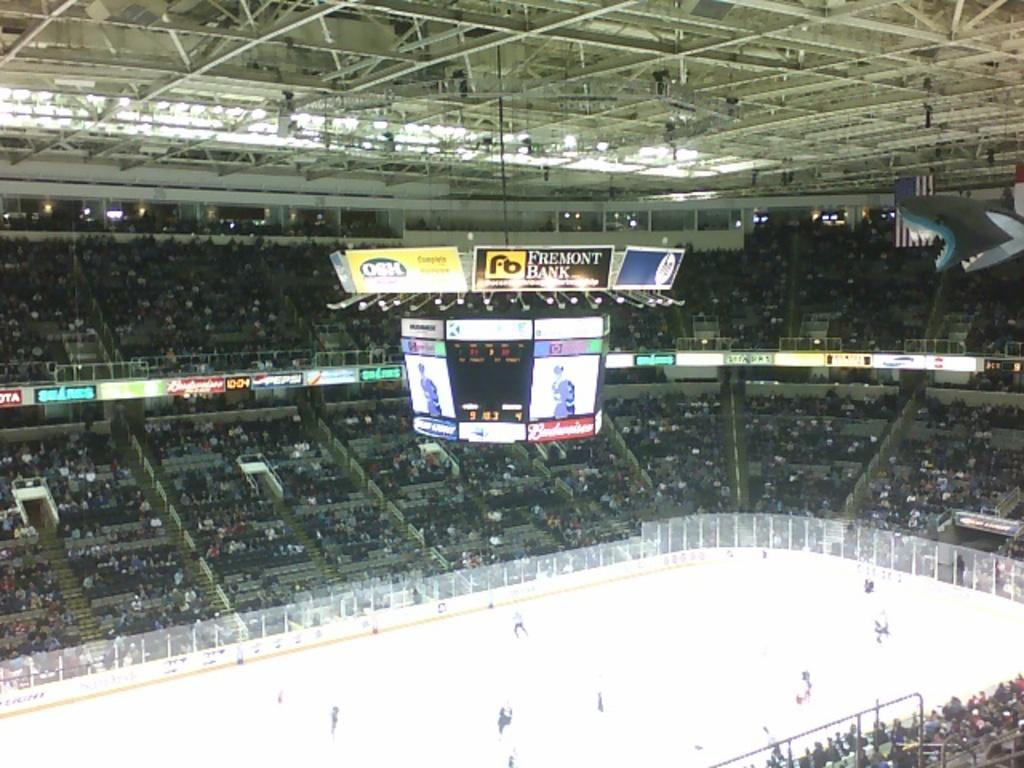<image>
Relay a brief, clear account of the picture shown. a high angle of a hockey stadium; ads hang above the screens for freemont bank and osh. 